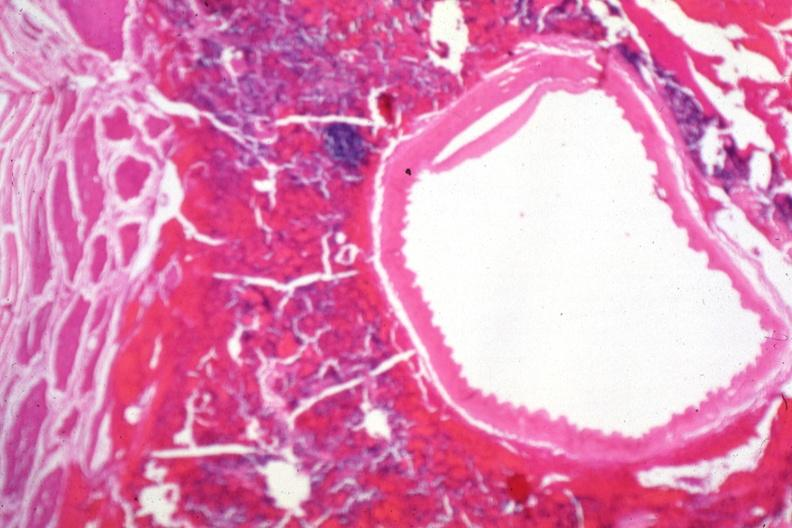s malignant adenoma present?
Answer the question using a single word or phrase. Yes 